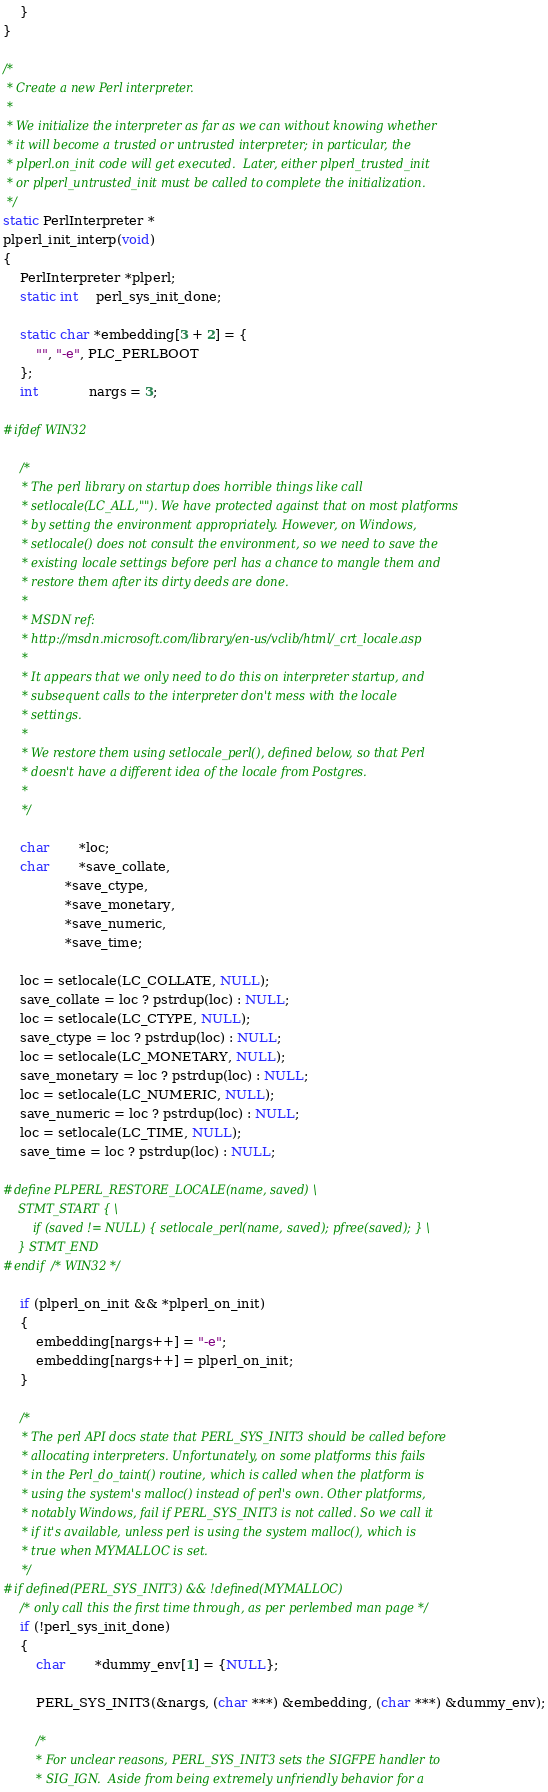Convert code to text. <code><loc_0><loc_0><loc_500><loc_500><_C_>	}
}

/*
 * Create a new Perl interpreter.
 *
 * We initialize the interpreter as far as we can without knowing whether
 * it will become a trusted or untrusted interpreter; in particular, the
 * plperl.on_init code will get executed.  Later, either plperl_trusted_init
 * or plperl_untrusted_init must be called to complete the initialization.
 */
static PerlInterpreter *
plperl_init_interp(void)
{
	PerlInterpreter *plperl;
	static int	perl_sys_init_done;

	static char *embedding[3 + 2] = {
		"", "-e", PLC_PERLBOOT
	};
	int			nargs = 3;

#ifdef WIN32

	/*
	 * The perl library on startup does horrible things like call
	 * setlocale(LC_ALL,""). We have protected against that on most platforms
	 * by setting the environment appropriately. However, on Windows,
	 * setlocale() does not consult the environment, so we need to save the
	 * existing locale settings before perl has a chance to mangle them and
	 * restore them after its dirty deeds are done.
	 *
	 * MSDN ref:
	 * http://msdn.microsoft.com/library/en-us/vclib/html/_crt_locale.asp
	 *
	 * It appears that we only need to do this on interpreter startup, and
	 * subsequent calls to the interpreter don't mess with the locale
	 * settings.
	 *
	 * We restore them using setlocale_perl(), defined below, so that Perl
	 * doesn't have a different idea of the locale from Postgres.
	 *
	 */

	char	   *loc;
	char	   *save_collate,
			   *save_ctype,
			   *save_monetary,
			   *save_numeric,
			   *save_time;

	loc = setlocale(LC_COLLATE, NULL);
	save_collate = loc ? pstrdup(loc) : NULL;
	loc = setlocale(LC_CTYPE, NULL);
	save_ctype = loc ? pstrdup(loc) : NULL;
	loc = setlocale(LC_MONETARY, NULL);
	save_monetary = loc ? pstrdup(loc) : NULL;
	loc = setlocale(LC_NUMERIC, NULL);
	save_numeric = loc ? pstrdup(loc) : NULL;
	loc = setlocale(LC_TIME, NULL);
	save_time = loc ? pstrdup(loc) : NULL;

#define PLPERL_RESTORE_LOCALE(name, saved) \
	STMT_START { \
		if (saved != NULL) { setlocale_perl(name, saved); pfree(saved); } \
	} STMT_END
#endif /* WIN32 */

	if (plperl_on_init && *plperl_on_init)
	{
		embedding[nargs++] = "-e";
		embedding[nargs++] = plperl_on_init;
	}

	/*
	 * The perl API docs state that PERL_SYS_INIT3 should be called before
	 * allocating interpreters. Unfortunately, on some platforms this fails
	 * in the Perl_do_taint() routine, which is called when the platform is
	 * using the system's malloc() instead of perl's own. Other platforms,
	 * notably Windows, fail if PERL_SYS_INIT3 is not called. So we call it
	 * if it's available, unless perl is using the system malloc(), which is
	 * true when MYMALLOC is set.
	 */
#if defined(PERL_SYS_INIT3) && !defined(MYMALLOC)
	/* only call this the first time through, as per perlembed man page */
	if (!perl_sys_init_done)
	{
		char	   *dummy_env[1] = {NULL};

		PERL_SYS_INIT3(&nargs, (char ***) &embedding, (char ***) &dummy_env);

		/*
		 * For unclear reasons, PERL_SYS_INIT3 sets the SIGFPE handler to
		 * SIG_IGN.  Aside from being extremely unfriendly behavior for a</code> 